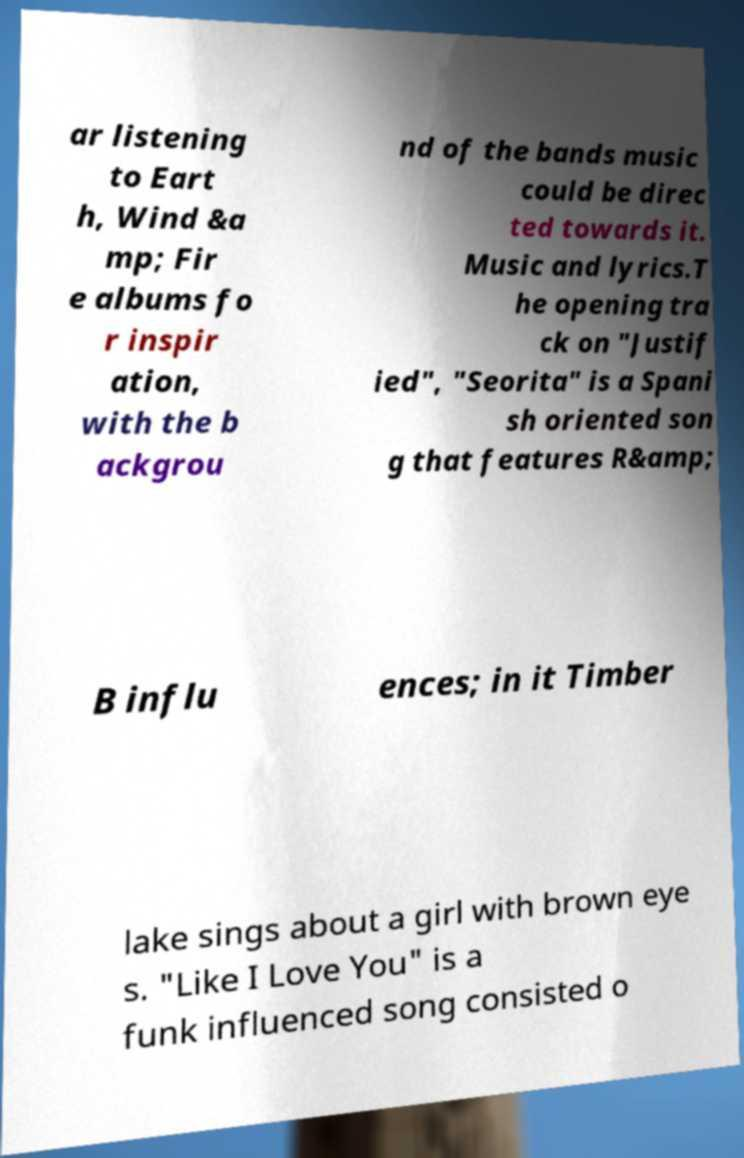Can you accurately transcribe the text from the provided image for me? ar listening to Eart h, Wind &a mp; Fir e albums fo r inspir ation, with the b ackgrou nd of the bands music could be direc ted towards it. Music and lyrics.T he opening tra ck on "Justif ied", "Seorita" is a Spani sh oriented son g that features R&amp; B influ ences; in it Timber lake sings about a girl with brown eye s. "Like I Love You" is a funk influenced song consisted o 